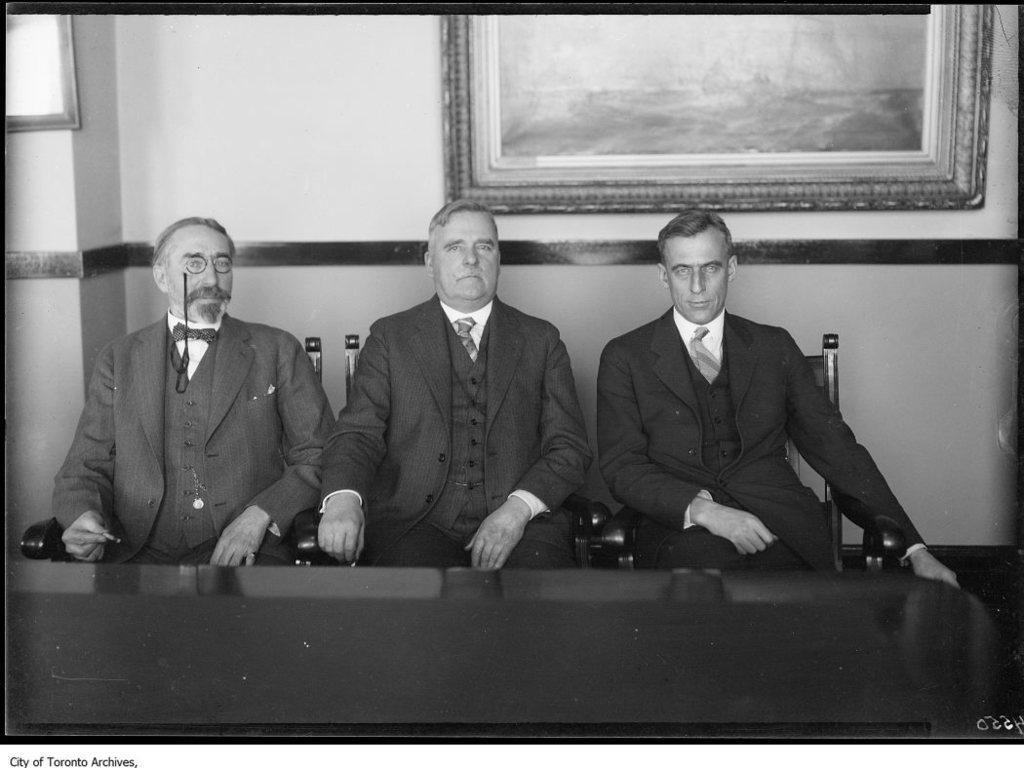Can you describe this image briefly? In this picture we can see three men wore blazers, ties and sitting on chairs and in front of them we can see a table and in the background we can see a wall with frames. 